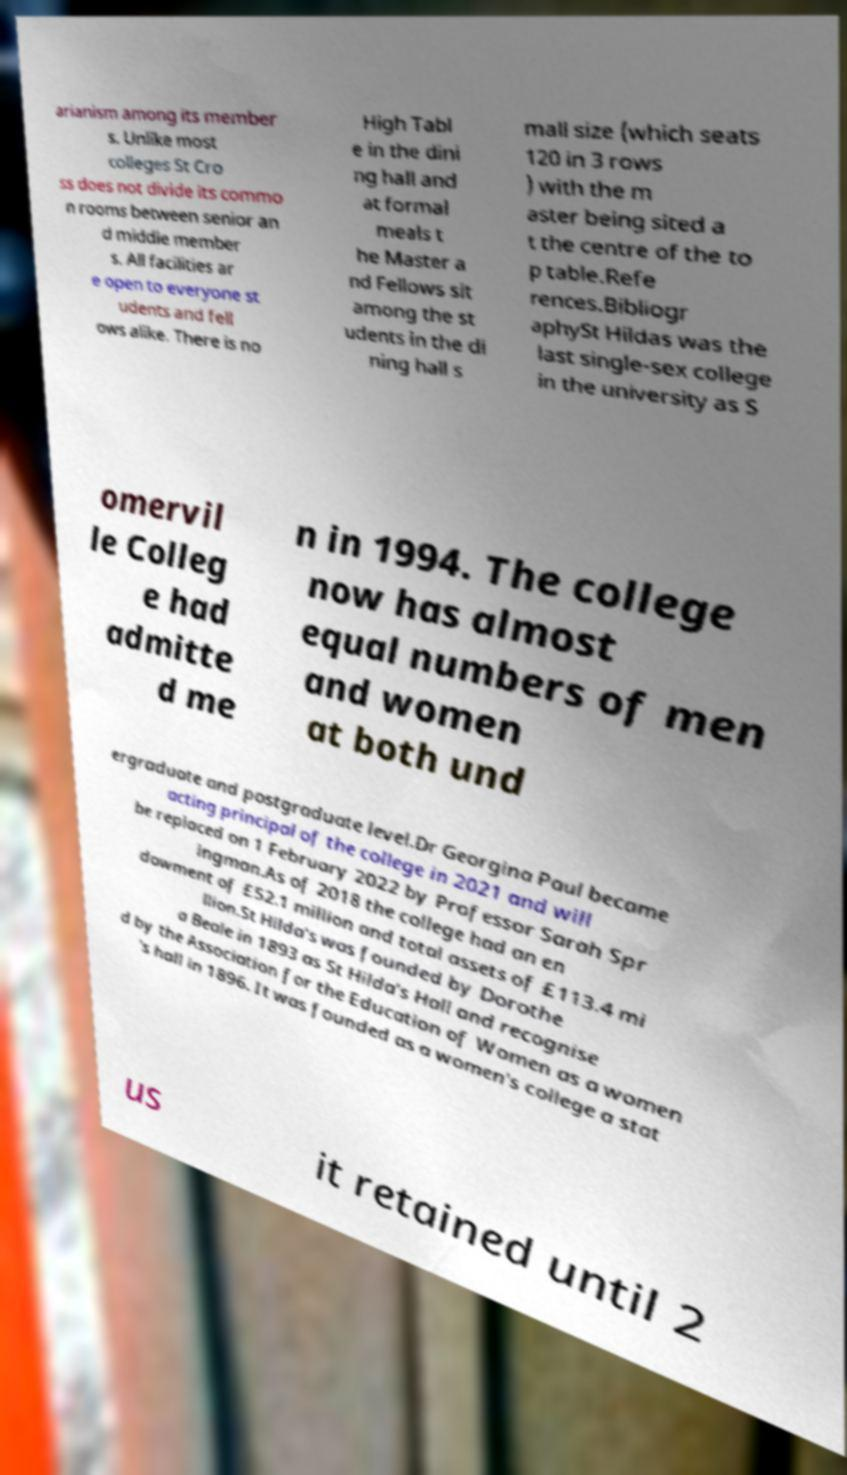I need the written content from this picture converted into text. Can you do that? arianism among its member s. Unlike most colleges St Cro ss does not divide its commo n rooms between senior an d middle member s. All facilities ar e open to everyone st udents and fell ows alike. There is no High Tabl e in the dini ng hall and at formal meals t he Master a nd Fellows sit among the st udents in the di ning hall s mall size (which seats 120 in 3 rows ) with the m aster being sited a t the centre of the to p table.Refe rences.Bibliogr aphySt Hildas was the last single-sex college in the university as S omervil le Colleg e had admitte d me n in 1994. The college now has almost equal numbers of men and women at both und ergraduate and postgraduate level.Dr Georgina Paul became acting principal of the college in 2021 and will be replaced on 1 February 2022 by Professor Sarah Spr ingman.As of 2018 the college had an en dowment of £52.1 million and total assets of £113.4 mi llion.St Hilda's was founded by Dorothe a Beale in 1893 as St Hilda's Hall and recognise d by the Association for the Education of Women as a women 's hall in 1896. It was founded as a women's college a stat us it retained until 2 